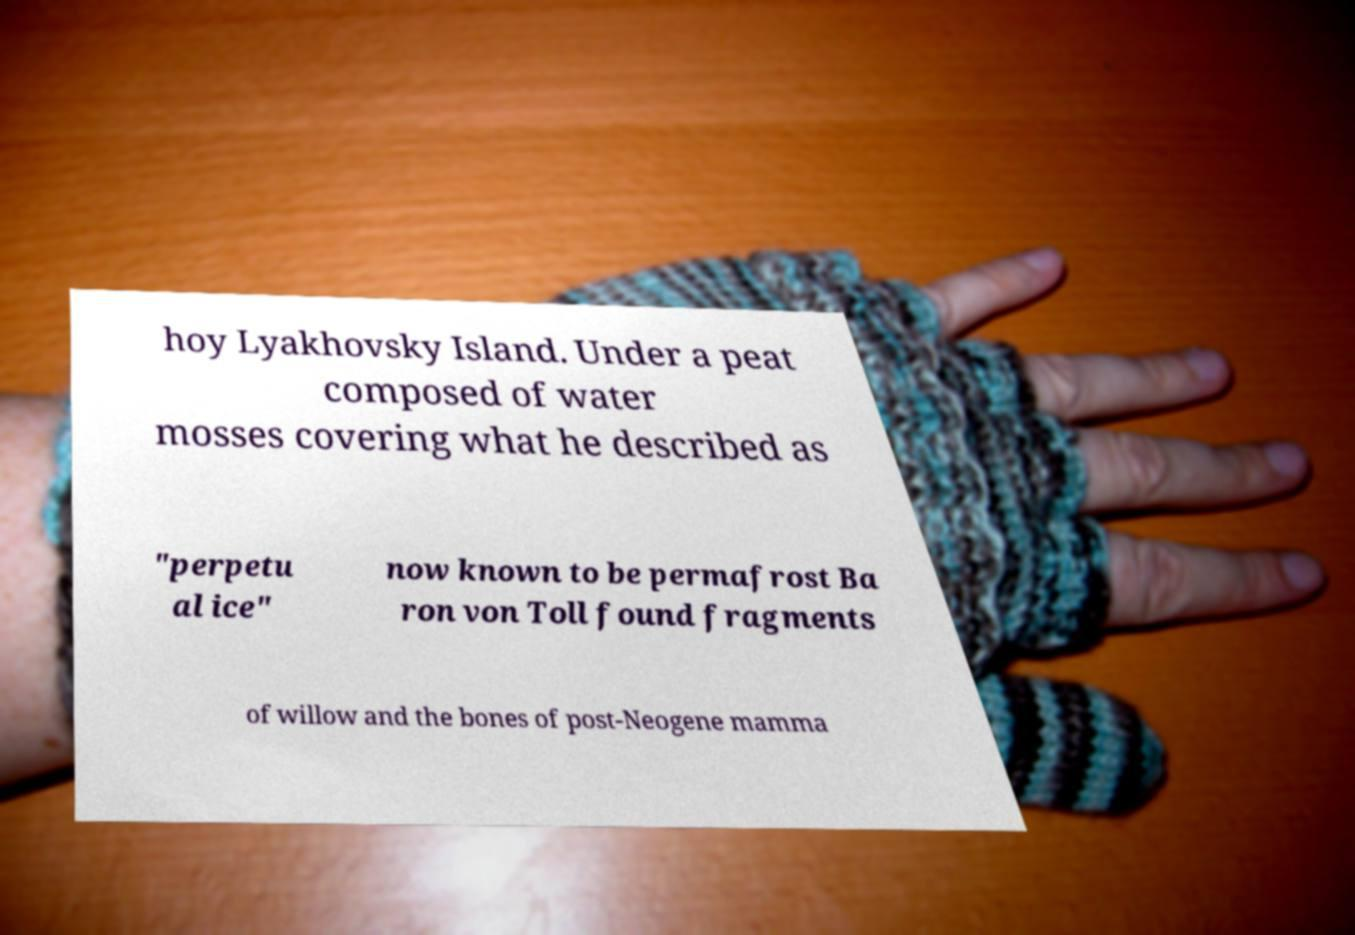Could you extract and type out the text from this image? hoy Lyakhovsky Island. Under a peat composed of water mosses covering what he described as "perpetu al ice" now known to be permafrost Ba ron von Toll found fragments of willow and the bones of post-Neogene mamma 